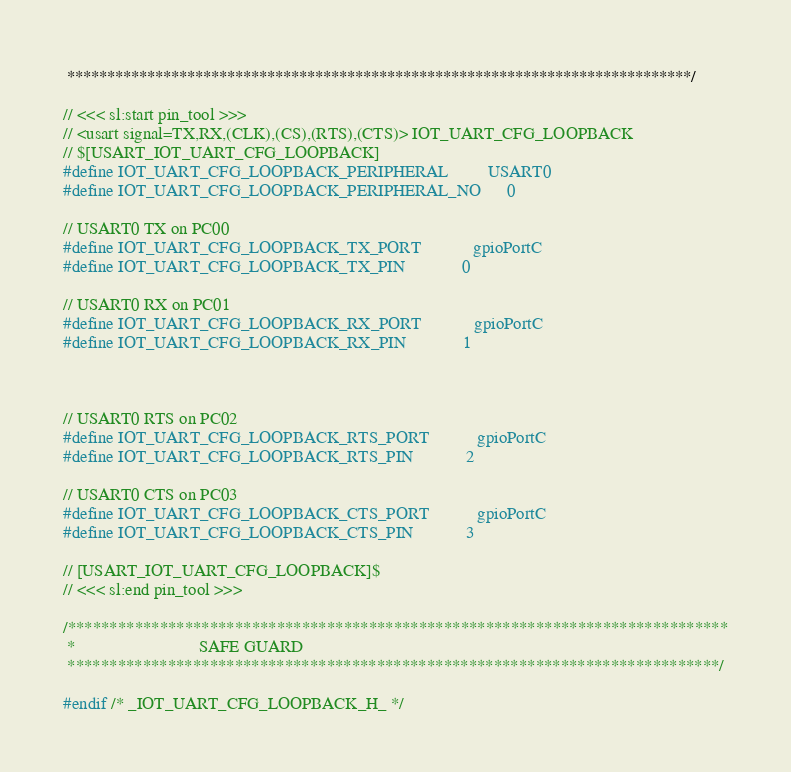Convert code to text. <code><loc_0><loc_0><loc_500><loc_500><_C_> ******************************************************************************/

// <<< sl:start pin_tool >>>
// <usart signal=TX,RX,(CLK),(CS),(RTS),(CTS)> IOT_UART_CFG_LOOPBACK
// $[USART_IOT_UART_CFG_LOOPBACK]
#define IOT_UART_CFG_LOOPBACK_PERIPHERAL         USART0
#define IOT_UART_CFG_LOOPBACK_PERIPHERAL_NO      0

// USART0 TX on PC00
#define IOT_UART_CFG_LOOPBACK_TX_PORT            gpioPortC
#define IOT_UART_CFG_LOOPBACK_TX_PIN             0

// USART0 RX on PC01
#define IOT_UART_CFG_LOOPBACK_RX_PORT            gpioPortC
#define IOT_UART_CFG_LOOPBACK_RX_PIN             1



// USART0 RTS on PC02
#define IOT_UART_CFG_LOOPBACK_RTS_PORT           gpioPortC
#define IOT_UART_CFG_LOOPBACK_RTS_PIN            2

// USART0 CTS on PC03
#define IOT_UART_CFG_LOOPBACK_CTS_PORT           gpioPortC
#define IOT_UART_CFG_LOOPBACK_CTS_PIN            3

// [USART_IOT_UART_CFG_LOOPBACK]$
// <<< sl:end pin_tool >>>

/*******************************************************************************
 *                            SAFE GUARD
 ******************************************************************************/

#endif /* _IOT_UART_CFG_LOOPBACK_H_ */
</code> 